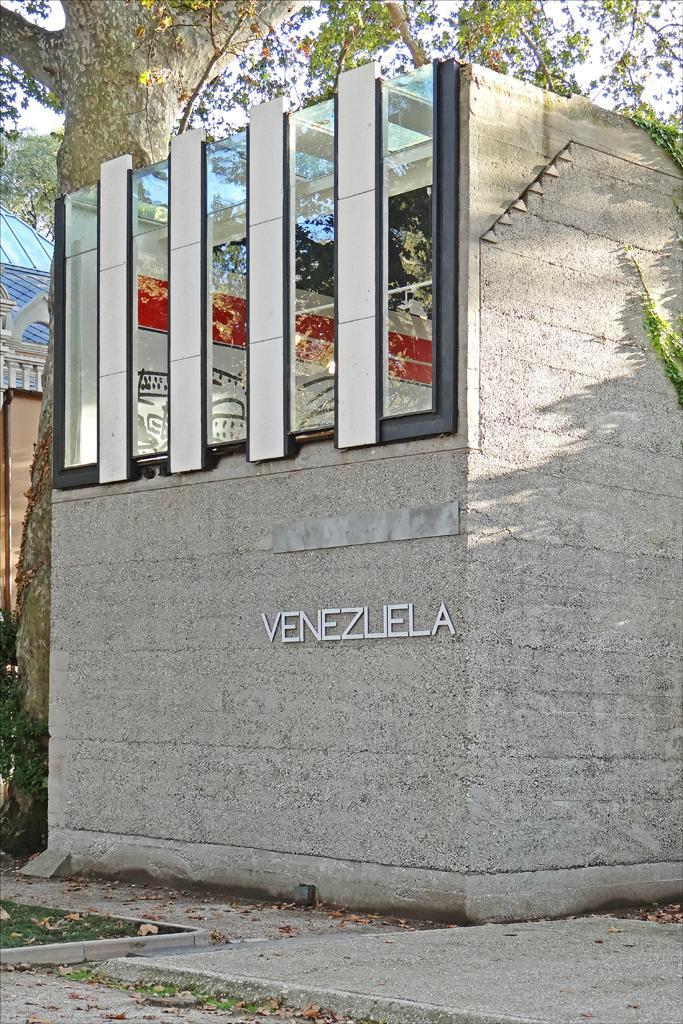In one or two sentences, can you explain what this image depicts? In the foreground of this image, at the bottom, there is grass, dry leaves and the ground. In the middle, there is a wall of a structure and some text on it. Behind it, there is a tree. On the left, there is a wall, tree, sky and the glass. 